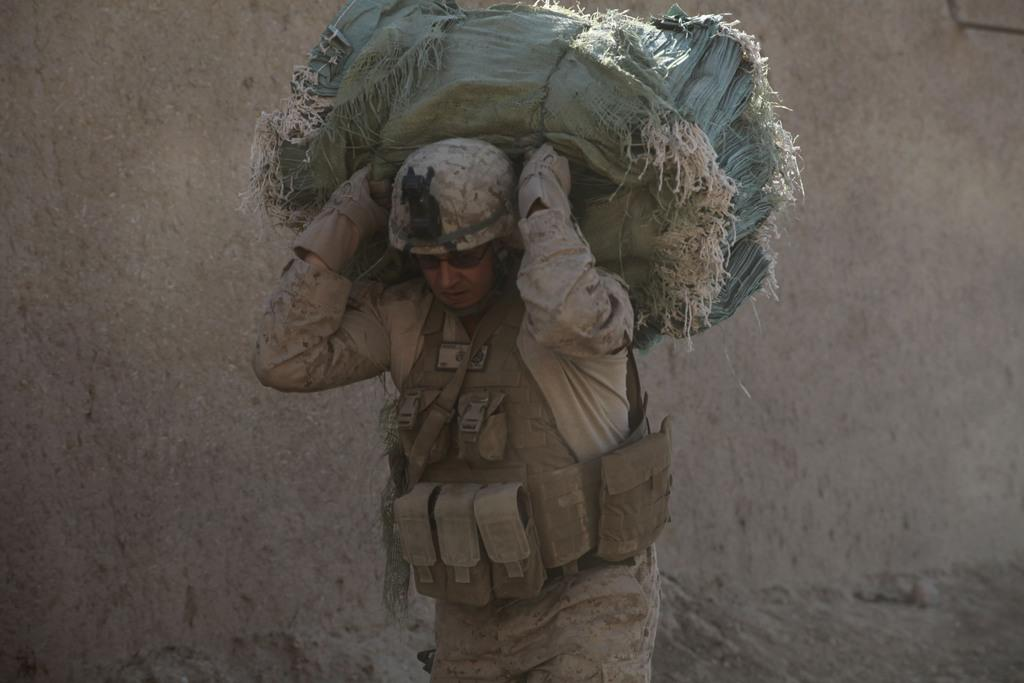What is the main subject of the image? There is a man standing in the center of the image. What is the man holding in the image? The man is holding bags. What type of protective gear is the man wearing? The man is wearing a helmet. What can be seen in the background of the image? There is a wall in the background of the image. What type of planes can be seen flying in the image? There are no planes visible in the image; it only features a man standing with bags and wearing a helmet, along with a wall in the background. 